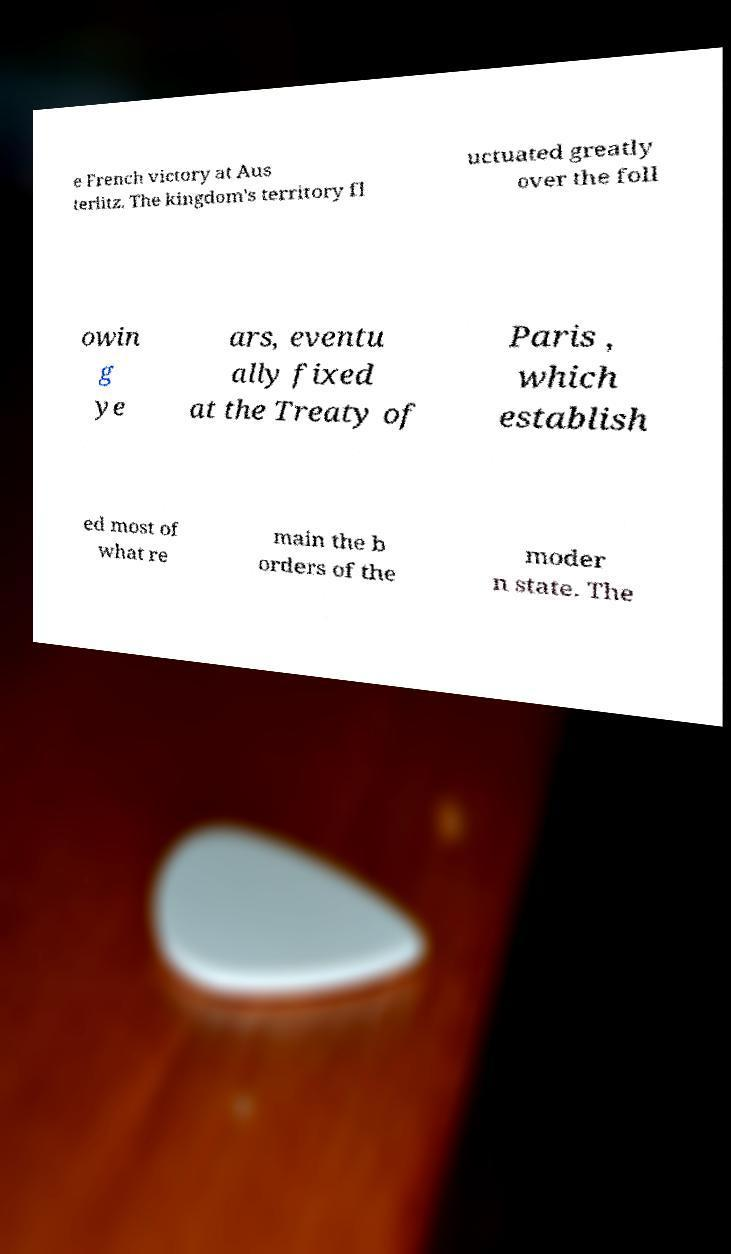Could you extract and type out the text from this image? e French victory at Aus terlitz. The kingdom's territory fl uctuated greatly over the foll owin g ye ars, eventu ally fixed at the Treaty of Paris , which establish ed most of what re main the b orders of the moder n state. The 